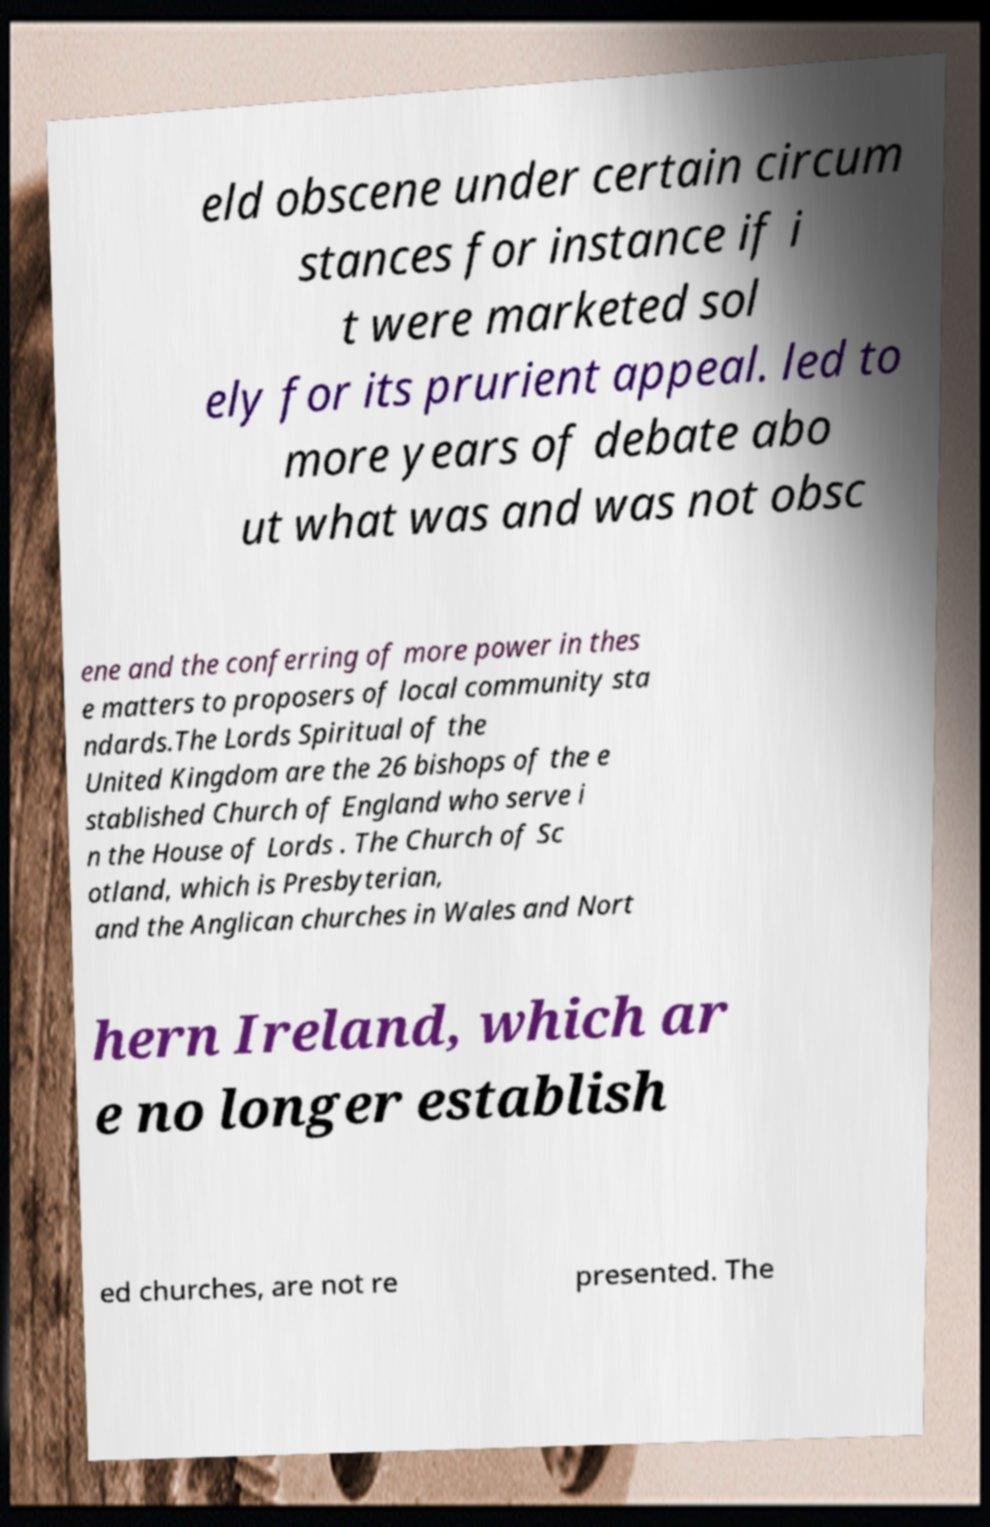Could you assist in decoding the text presented in this image and type it out clearly? eld obscene under certain circum stances for instance if i t were marketed sol ely for its prurient appeal. led to more years of debate abo ut what was and was not obsc ene and the conferring of more power in thes e matters to proposers of local community sta ndards.The Lords Spiritual of the United Kingdom are the 26 bishops of the e stablished Church of England who serve i n the House of Lords . The Church of Sc otland, which is Presbyterian, and the Anglican churches in Wales and Nort hern Ireland, which ar e no longer establish ed churches, are not re presented. The 